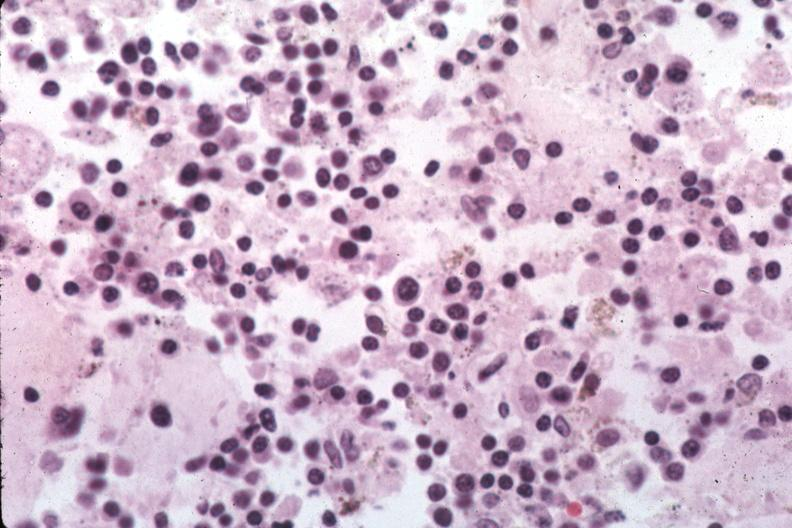what is present?
Answer the question using a single word or phrase. Hematologic 